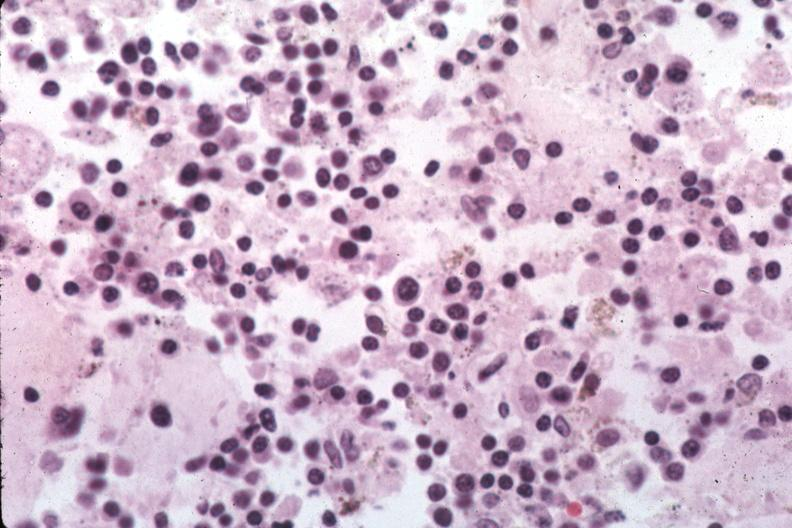what is present?
Answer the question using a single word or phrase. Hematologic 